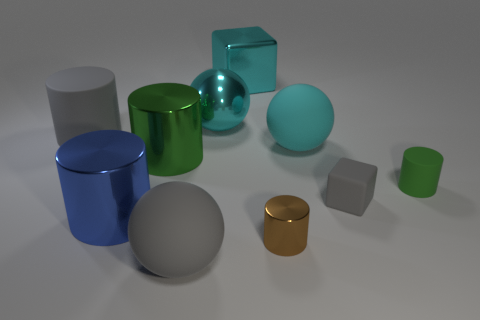Subtract all tiny cylinders. How many cylinders are left? 3 Subtract 3 balls. How many balls are left? 0 Subtract all blue cylinders. How many cylinders are left? 4 Subtract all balls. How many objects are left? 7 Subtract all red cylinders. Subtract all gray spheres. How many cylinders are left? 5 Subtract all yellow cubes. How many cyan spheres are left? 2 Subtract all tiny things. Subtract all cylinders. How many objects are left? 2 Add 6 large metal cubes. How many large metal cubes are left? 7 Add 2 rubber cylinders. How many rubber cylinders exist? 4 Subtract 0 red spheres. How many objects are left? 10 